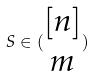Convert formula to latex. <formula><loc_0><loc_0><loc_500><loc_500>S \in ( \begin{matrix} [ n ] \\ m \end{matrix} )</formula> 